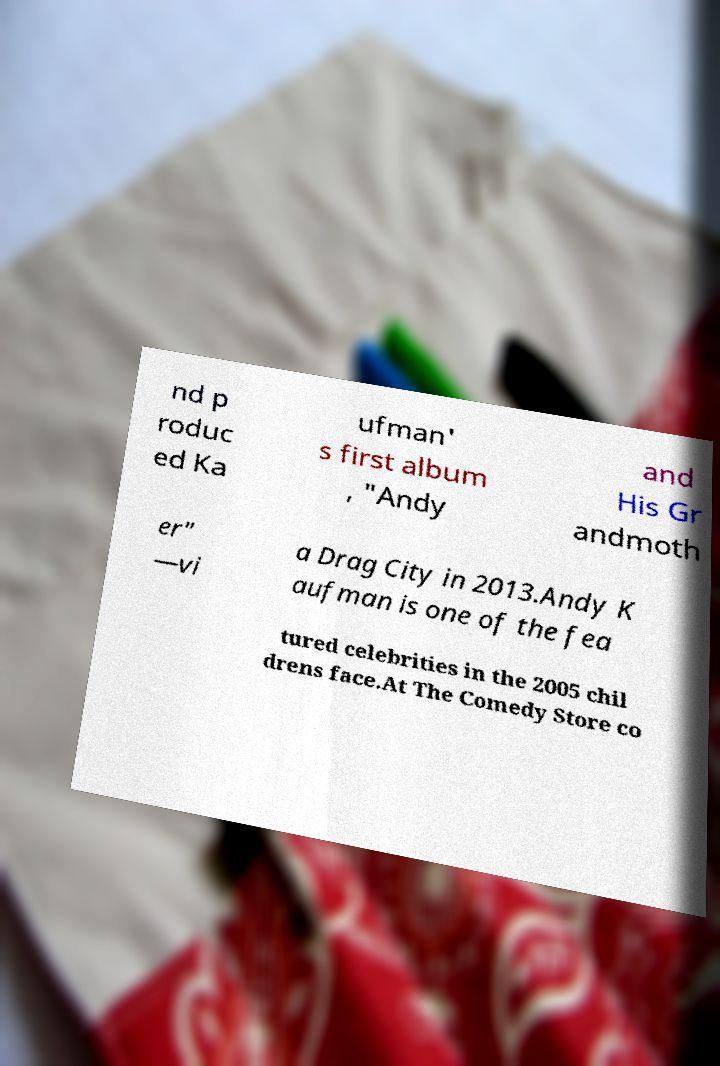Can you read and provide the text displayed in the image?This photo seems to have some interesting text. Can you extract and type it out for me? nd p roduc ed Ka ufman' s first album , "Andy and His Gr andmoth er" —vi a Drag City in 2013.Andy K aufman is one of the fea tured celebrities in the 2005 chil drens face.At The Comedy Store co 